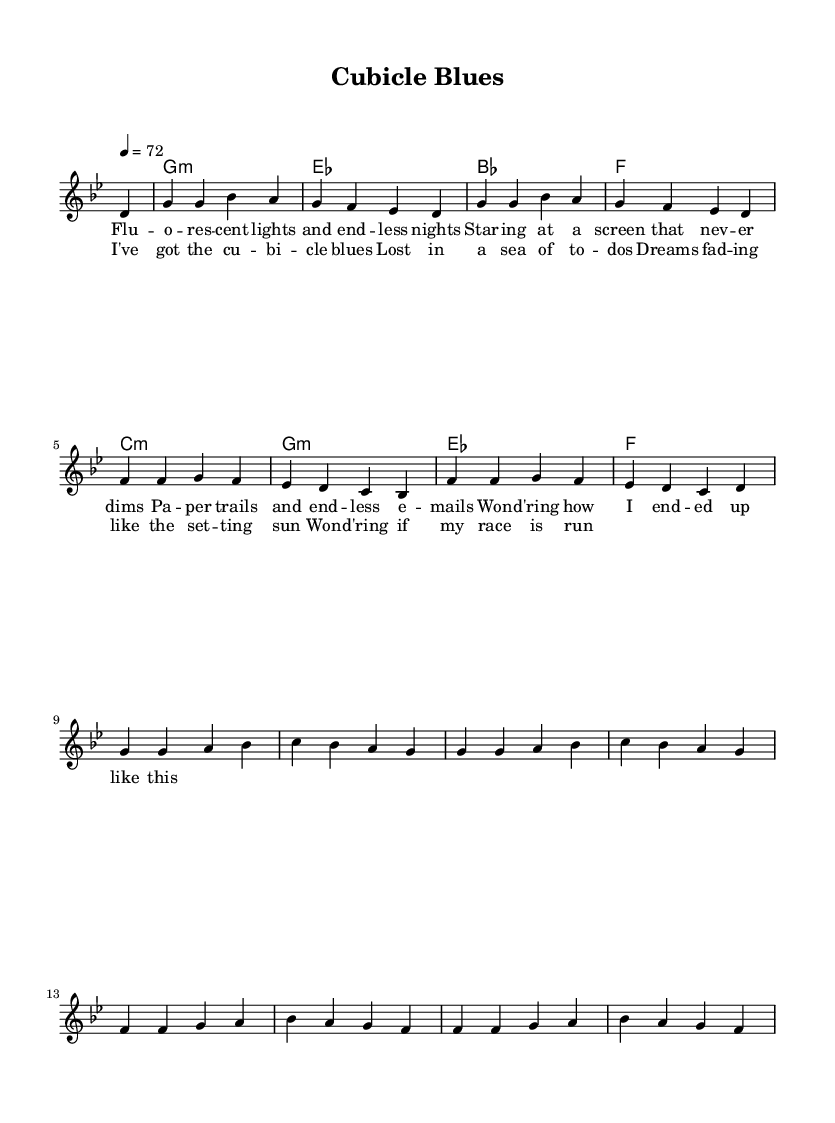What is the key signature of this music? The key signature is G minor, which has two flats: B flat and E flat. You can identify this by looking at the key signature notations at the beginning of the piece.
Answer: G minor What is the time signature of this music? The time signature is 4/4, meaning there are four beats in each measure, and it is a common time signature used in many genres, including country rock. This can be seen at the start of the score.
Answer: 4/4 What is the tempo marking for this piece? The tempo marking is 72 beats per minute, indicated by the number placed above the staff which shows how many beats are played in a minute.
Answer: 72 How many measures are in the melody? There are 8 measures in the melody section specifically indicated by the notation and the way the melody is laid out in the score. Each measure is separated visually by bar lines.
Answer: 8 What are the primary themes addressed in the lyrics? The primary themes explore feelings of career burnout, dissatisfaction, and reflection on work-life balance. This is evident from the lyrics which mention "cubicle blues" and "wondering how I ended up like this."
Answer: Career burnout Which chord appears most frequently in this piece? The G minor chord appears most frequently, as it is one of the primary chords used throughout the music, consistent with the chord structure seen in the score.
Answer: G minor 